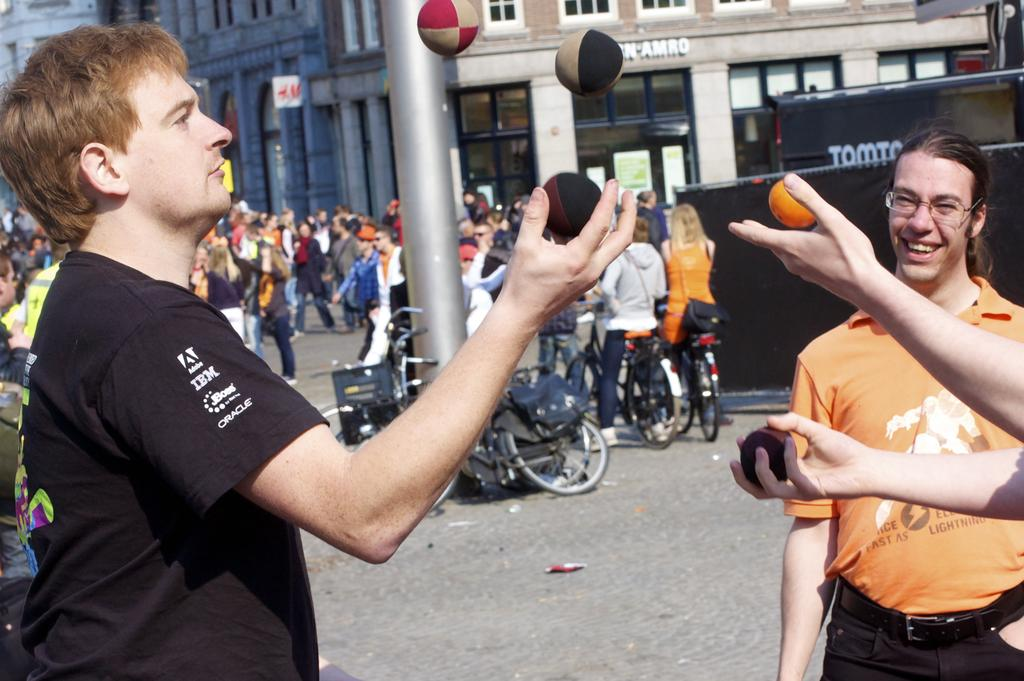What can be seen in the front of the image? There are people and balls in the front of the image. What is visible in the background of the image? There are bicycles, a pole, people, buildings, posters, and black objects in the background of the image. What type of game are the people playing with their feet in the image? There is no game or feet visible in the image. Can you tell me how many horses are present in the image? There are no horses present in the image. 